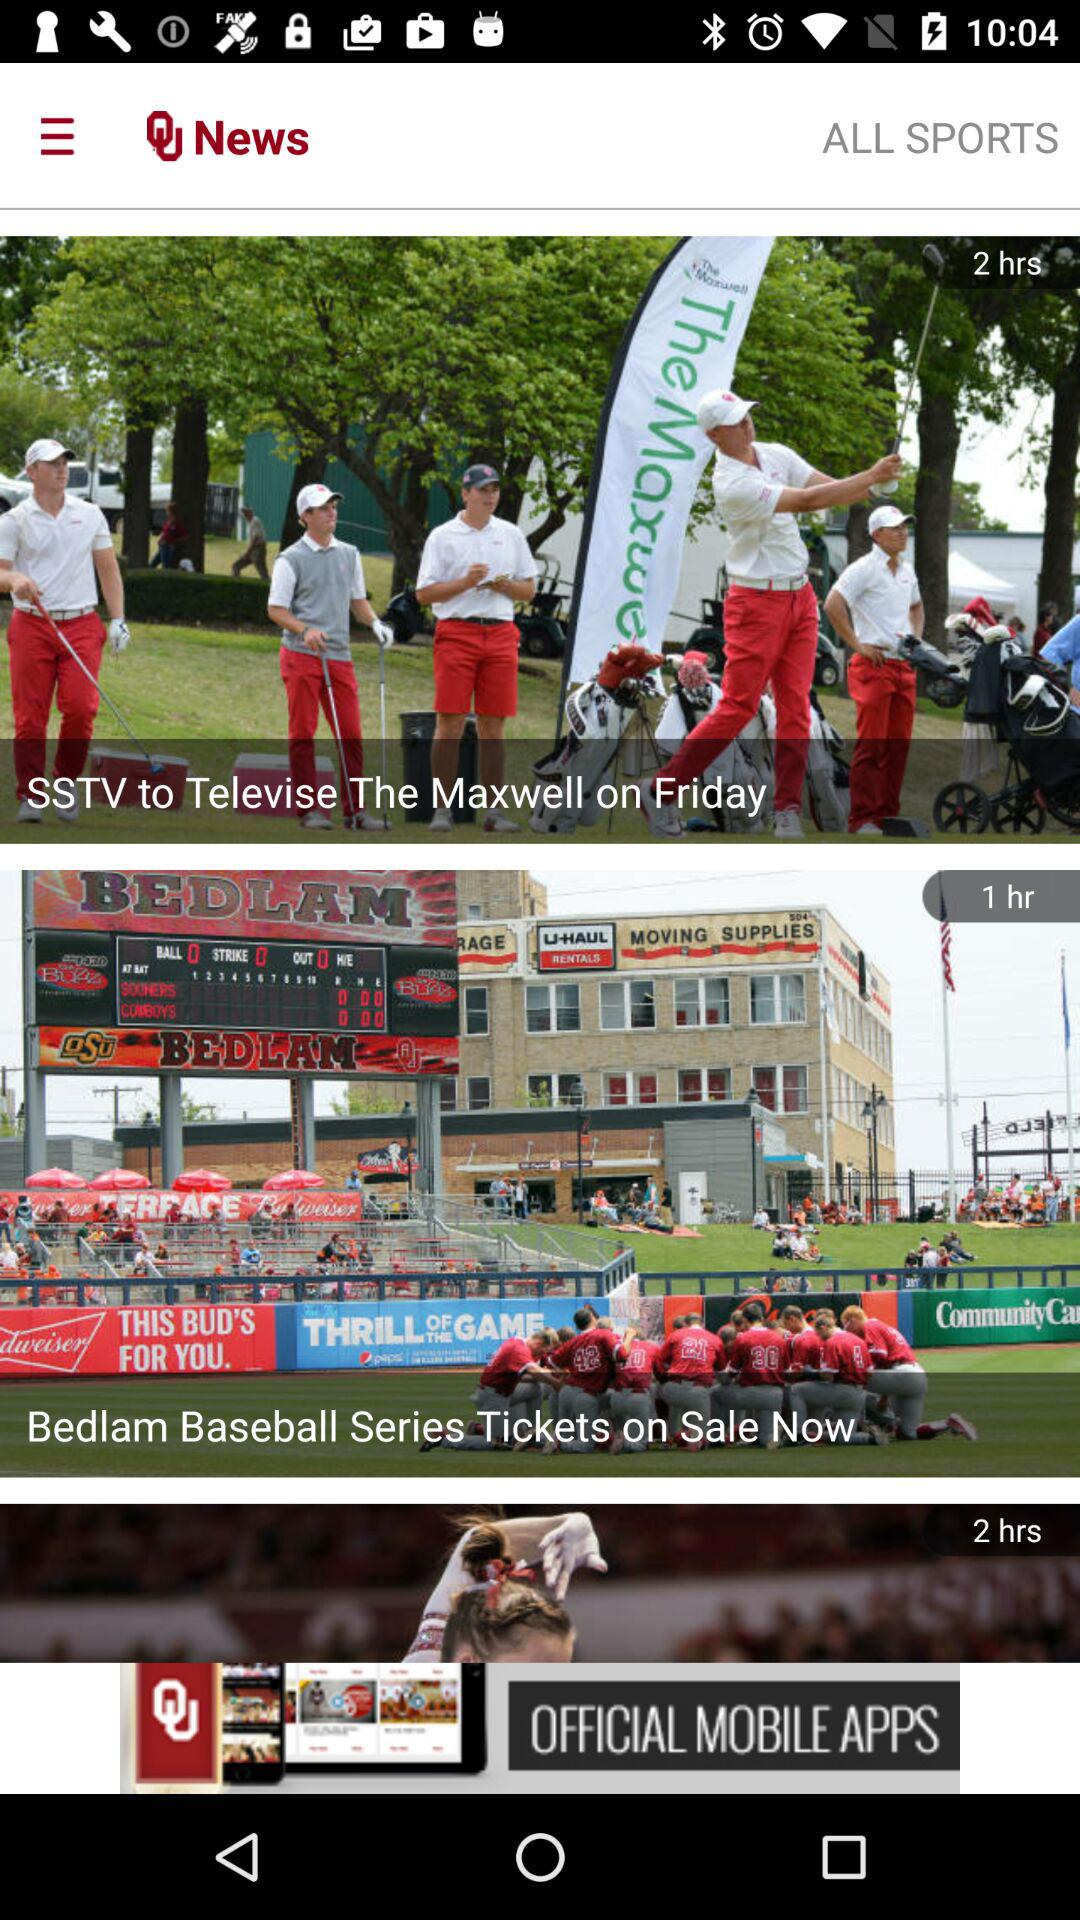How many hours ago were the baseball tickets released?
Answer the question using a single word or phrase. 1 hr 